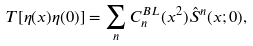Convert formula to latex. <formula><loc_0><loc_0><loc_500><loc_500>T [ \eta ( x ) \eta ( 0 ) ] = \sum _ { n } C _ { n } ^ { B L } ( x ^ { 2 } ) { \hat { S } } ^ { n } ( x ; 0 ) ,</formula> 